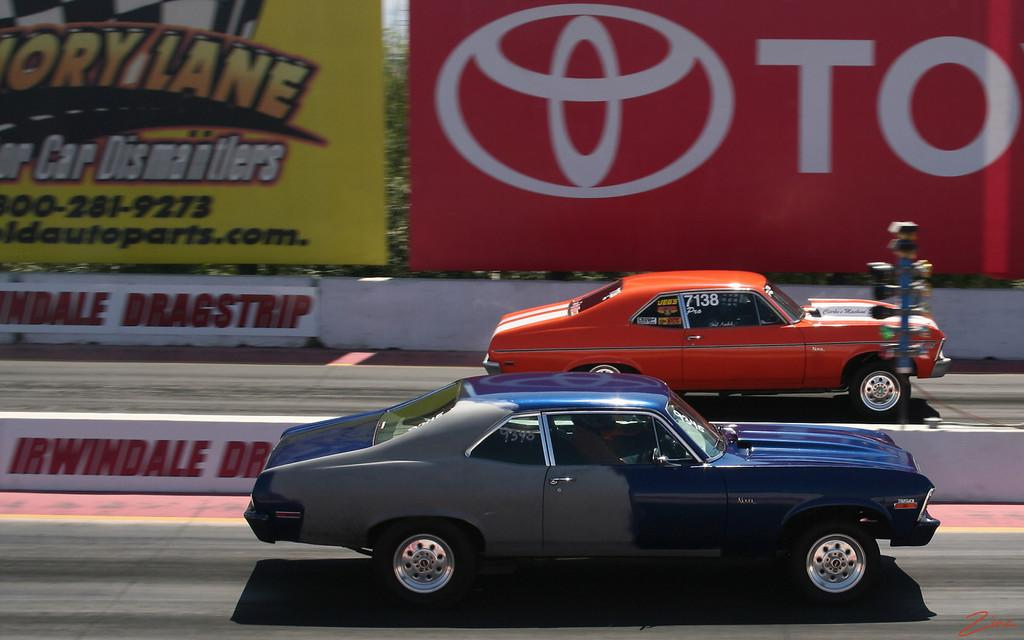How many cars are present in the image? There are two cars in the image. What colors are the cars? One car is blue, and the other is orange. What can be seen in the image besides the cars? There is a red and yellow color banner and trees visible in the image. What type of leather is used to make the forks in the image? There are no forks present in the image, so it is not possible to determine what type of leather might be used. 